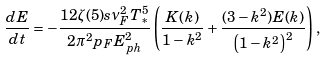<formula> <loc_0><loc_0><loc_500><loc_500>\frac { d E } { d t } = - \frac { 1 2 \zeta ( 5 ) s \nu _ { F } ^ { 2 } T _ { * } ^ { 5 } } { 2 \pi ^ { 2 } p _ { F } E _ { p h } ^ { 2 } } \left ( \frac { K ( k ) } { 1 - k ^ { 2 } } + \frac { ( 3 - k ^ { 2 } ) E ( k ) } { \left ( 1 - k ^ { 2 } \right ) ^ { 2 } } \right ) ,</formula> 